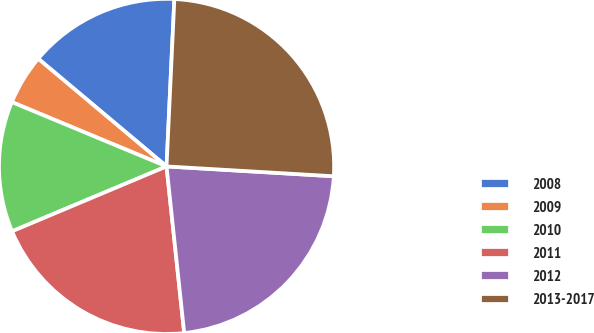Convert chart. <chart><loc_0><loc_0><loc_500><loc_500><pie_chart><fcel>2008<fcel>2009<fcel>2010<fcel>2011<fcel>2012<fcel>2013-2017<nl><fcel>14.63%<fcel>4.84%<fcel>12.6%<fcel>20.35%<fcel>22.38%<fcel>25.19%<nl></chart> 